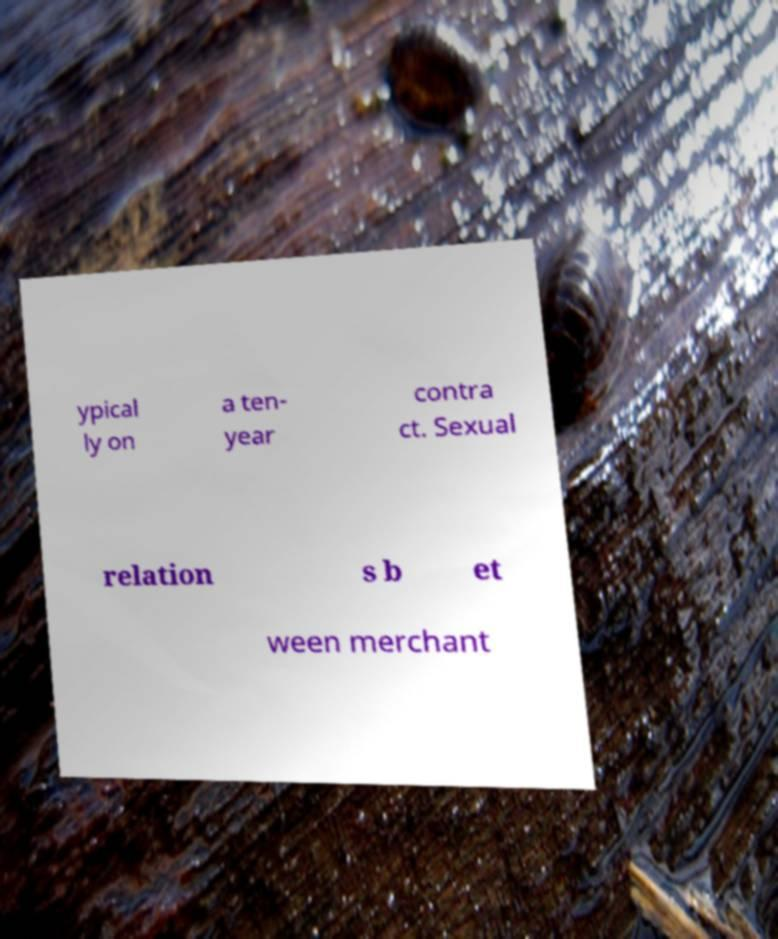I need the written content from this picture converted into text. Can you do that? ypical ly on a ten- year contra ct. Sexual relation s b et ween merchant 